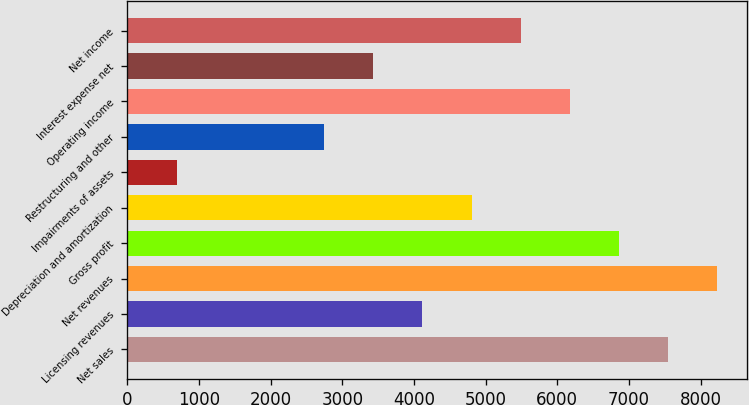<chart> <loc_0><loc_0><loc_500><loc_500><bar_chart><fcel>Net sales<fcel>Licensing revenues<fcel>Net revenues<fcel>Gross profit<fcel>Depreciation and amortization<fcel>Impairments of assets<fcel>Restructuring and other<fcel>Operating income<fcel>Interest expense net<fcel>Net income<nl><fcel>7545.92<fcel>4116.32<fcel>8231.84<fcel>6860<fcel>4802.24<fcel>686.72<fcel>2744.48<fcel>6174.08<fcel>3430.4<fcel>5488.16<nl></chart> 